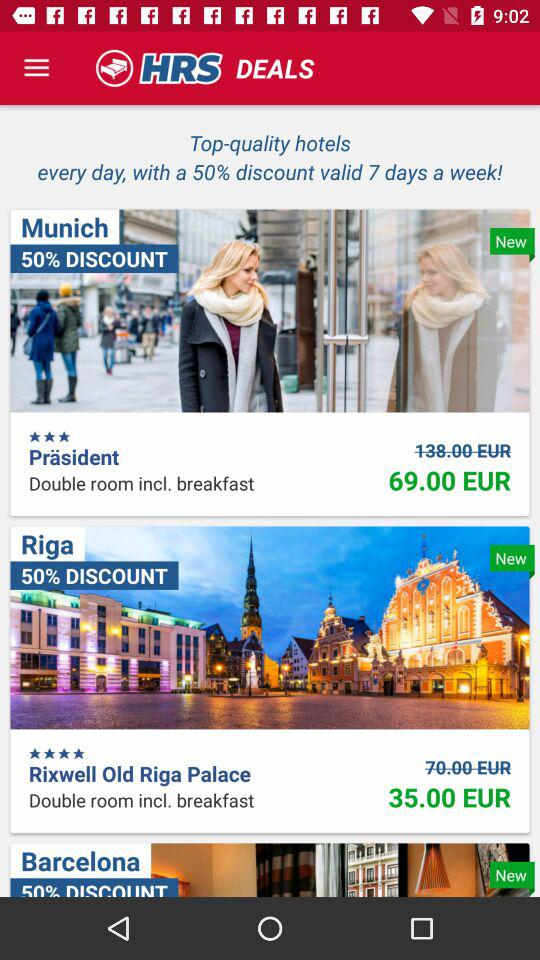What is the discounted rent for a room in the "Rixwell Old Riga Palace"? The discounted rent for a room in the "Rixwell Old Riga Palace" is 35.00 EUR. 